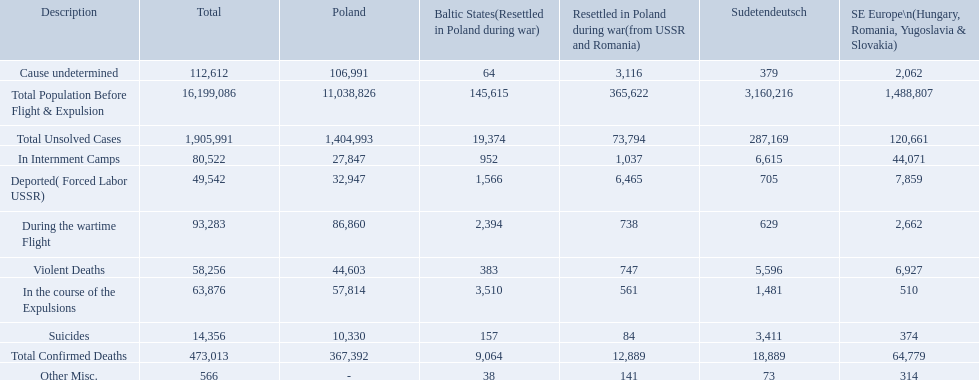What were all of the types of deaths? Violent Deaths, Suicides, Deported( Forced Labor USSR), In Internment Camps, During the wartime Flight, In the course of the Expulsions, Cause undetermined, Other Misc. And their totals in the baltic states? 383, 157, 1,566, 952, 2,394, 3,510, 64, 38. Were more deaths in the baltic states caused by undetermined causes or misc.? Cause undetermined. 